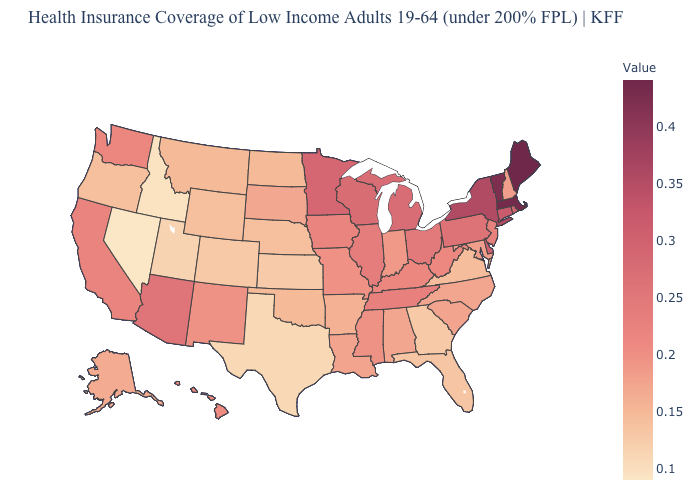Does the map have missing data?
Concise answer only. No. Among the states that border Maryland , which have the lowest value?
Answer briefly. Virginia. Does Kansas have the lowest value in the MidWest?
Short answer required. Yes. 